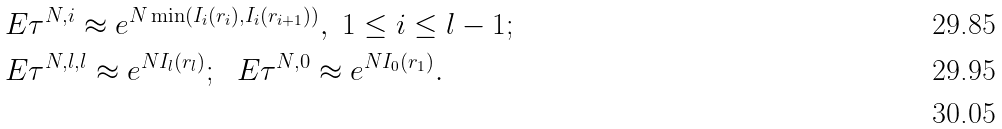Convert formula to latex. <formula><loc_0><loc_0><loc_500><loc_500>& E \tau ^ { N , i } \approx e ^ { N \min \left ( I _ { i } ( r _ { i } ) , I _ { i } ( r _ { i + 1 } ) \right ) } , \ 1 \leq i \leq l - 1 ; \\ & E \tau ^ { N , l , l } \approx e ^ { N I _ { l } ( r _ { l } ) } ; \ \ E \tau ^ { N , 0 } \approx e ^ { N I _ { 0 } ( r _ { 1 } ) } . \\</formula> 